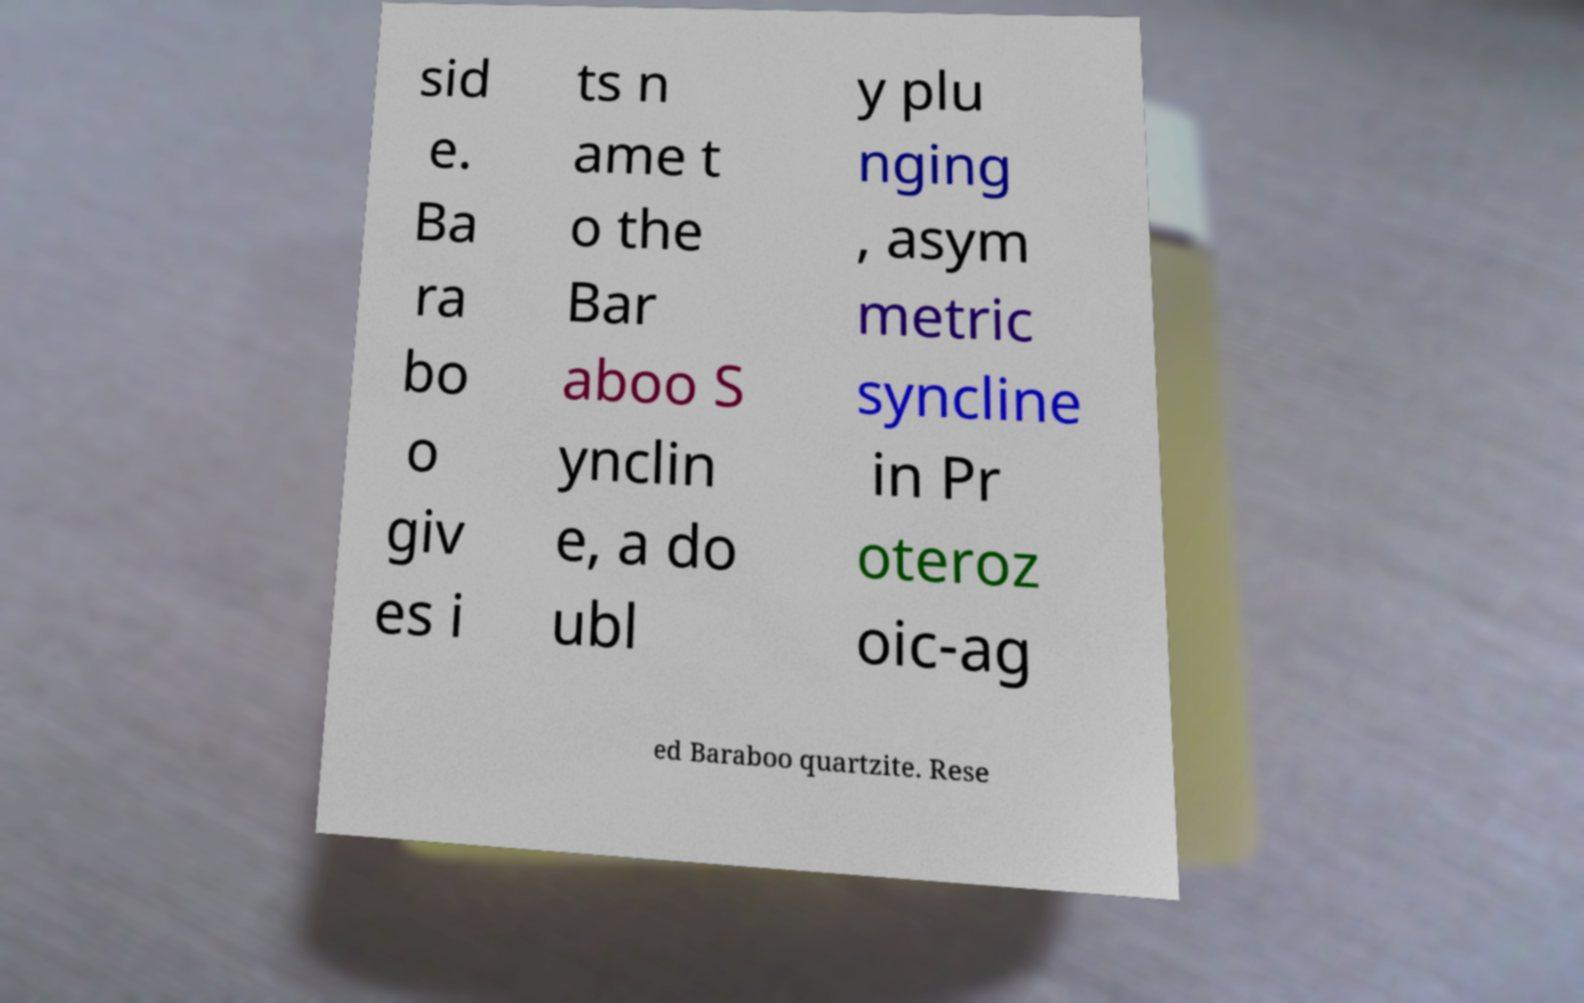Please read and relay the text visible in this image. What does it say? sid e. Ba ra bo o giv es i ts n ame t o the Bar aboo S ynclin e, a do ubl y plu nging , asym metric syncline in Pr oteroz oic-ag ed Baraboo quartzite. Rese 